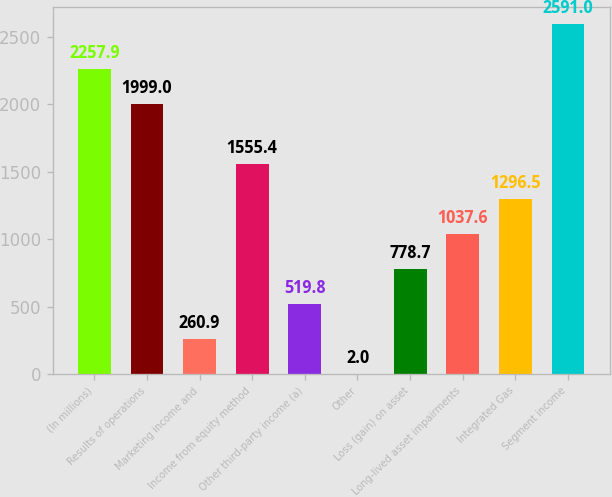<chart> <loc_0><loc_0><loc_500><loc_500><bar_chart><fcel>(In millions)<fcel>Results of operations<fcel>Marketing income and<fcel>Income from equity method<fcel>Other third-party income (a)<fcel>Other<fcel>Loss (gain) on asset<fcel>Long-lived asset impairments<fcel>Integrated Gas<fcel>Segment income<nl><fcel>2257.9<fcel>1999<fcel>260.9<fcel>1555.4<fcel>519.8<fcel>2<fcel>778.7<fcel>1037.6<fcel>1296.5<fcel>2591<nl></chart> 